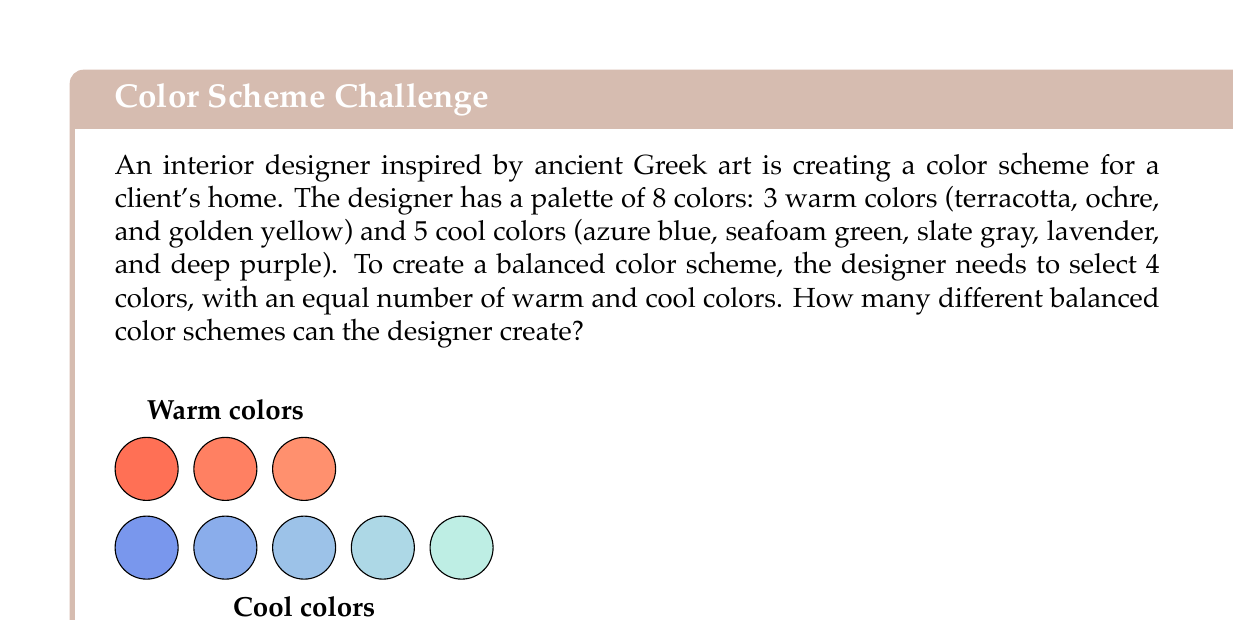Solve this math problem. To solve this problem, we need to use the combination formula and the multiplication principle of counting. Let's break it down step-by-step:

1) We need to choose 2 warm colors out of 3, and 2 cool colors out of 5.

2) For the warm colors, we use the combination formula:
   $$\binom{3}{2} = \frac{3!}{2!(3-2)!} = \frac{3 \cdot 2 \cdot 1}{(2 \cdot 1)(1)} = 3$$

3) For the cool colors, we again use the combination formula:
   $$\binom{5}{2} = \frac{5!}{2!(5-2)!} = \frac{5 \cdot 4 \cdot 3 \cdot 2 \cdot 1}{(2 \cdot 1)(3 \cdot 2 \cdot 1)} = 10$$

4) By the multiplication principle, the total number of ways to choose 2 warm colors AND 2 cool colors is:
   $$3 \cdot 10 = 30$$

Therefore, the designer can create 30 different balanced color schemes.
Answer: 30 